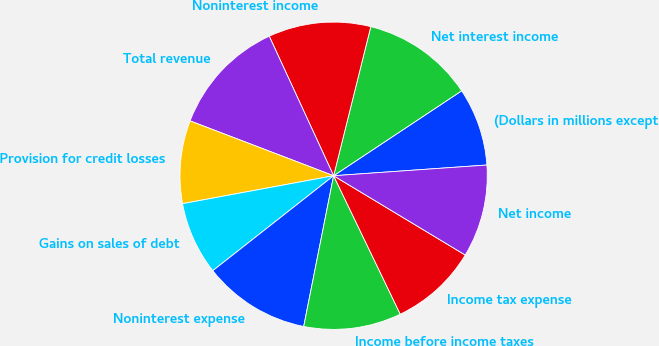Convert chart. <chart><loc_0><loc_0><loc_500><loc_500><pie_chart><fcel>(Dollars in millions except<fcel>Net interest income<fcel>Noninterest income<fcel>Total revenue<fcel>Provision for credit losses<fcel>Gains on sales of debt<fcel>Noninterest expense<fcel>Income before income taxes<fcel>Income tax expense<fcel>Net income<nl><fcel>8.21%<fcel>11.79%<fcel>10.77%<fcel>12.31%<fcel>8.72%<fcel>7.69%<fcel>11.28%<fcel>10.26%<fcel>9.23%<fcel>9.74%<nl></chart> 